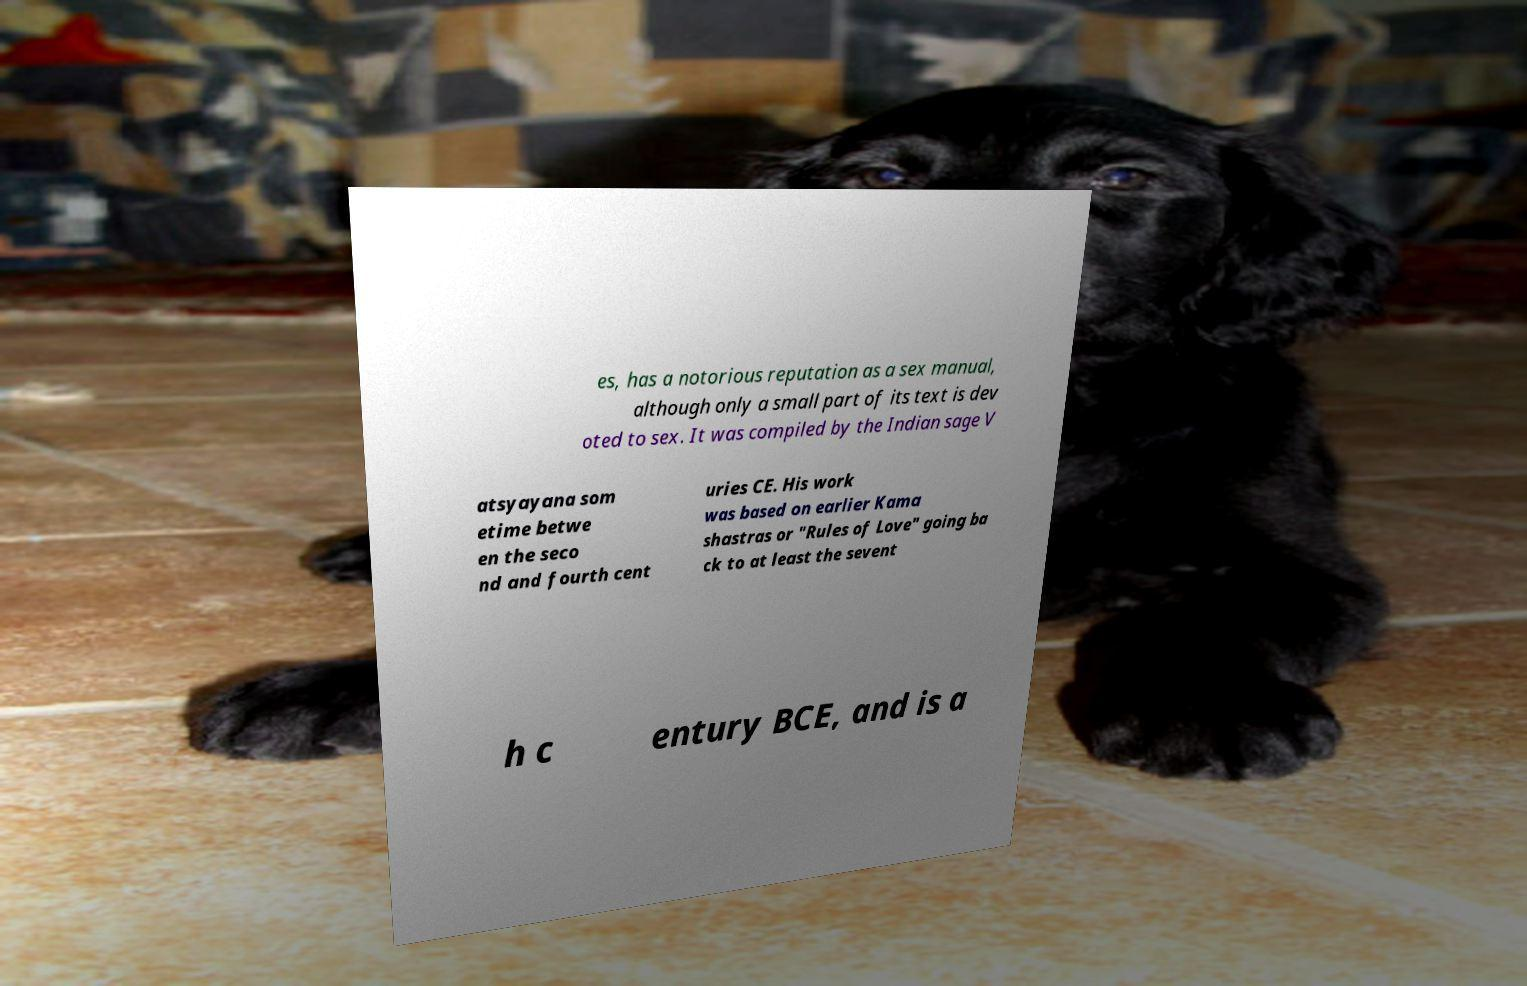There's text embedded in this image that I need extracted. Can you transcribe it verbatim? es, has a notorious reputation as a sex manual, although only a small part of its text is dev oted to sex. It was compiled by the Indian sage V atsyayana som etime betwe en the seco nd and fourth cent uries CE. His work was based on earlier Kama shastras or "Rules of Love" going ba ck to at least the sevent h c entury BCE, and is a 